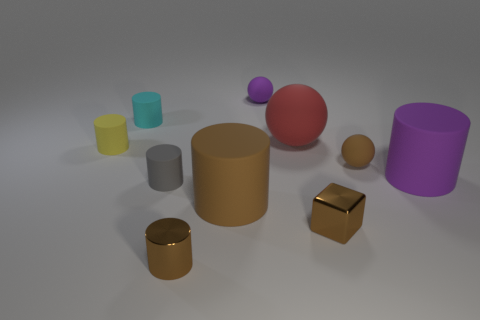How many large things are blue rubber balls or cubes?
Provide a short and direct response. 0. Are there the same number of brown metal cylinders left of the cyan rubber thing and large purple rubber cylinders that are on the right side of the tiny gray cylinder?
Make the answer very short. No. What number of other objects are there of the same color as the metallic block?
Offer a terse response. 3. Are there an equal number of small gray things right of the gray cylinder and shiny spheres?
Keep it short and to the point. Yes. Is the size of the purple ball the same as the brown shiny cylinder?
Offer a terse response. Yes. There is a tiny cylinder that is both behind the purple cylinder and in front of the cyan matte thing; what is its material?
Provide a succinct answer. Rubber. How many other brown things have the same shape as the large brown thing?
Keep it short and to the point. 1. What is the material of the purple thing that is behind the brown ball?
Offer a very short reply. Rubber. Is the number of brown things behind the purple matte cylinder less than the number of tiny yellow cylinders?
Ensure brevity in your answer.  No. Is the shape of the small cyan rubber thing the same as the small gray rubber object?
Offer a terse response. Yes. 